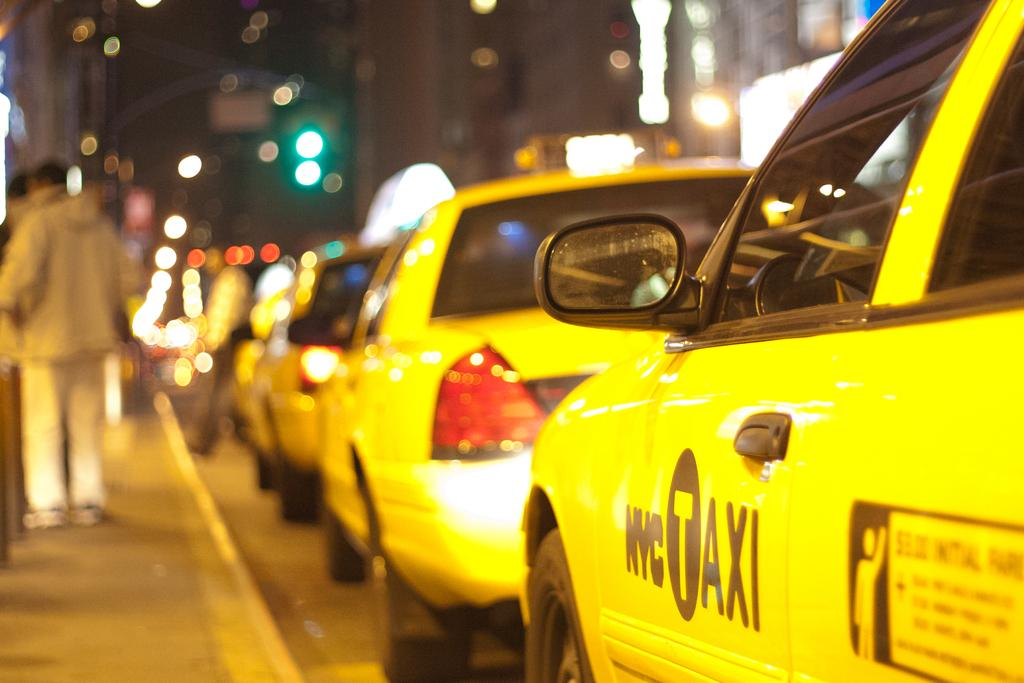<image>
Write a terse but informative summary of the picture. A long line of NYC taxi cabs are lined up along the curb. 